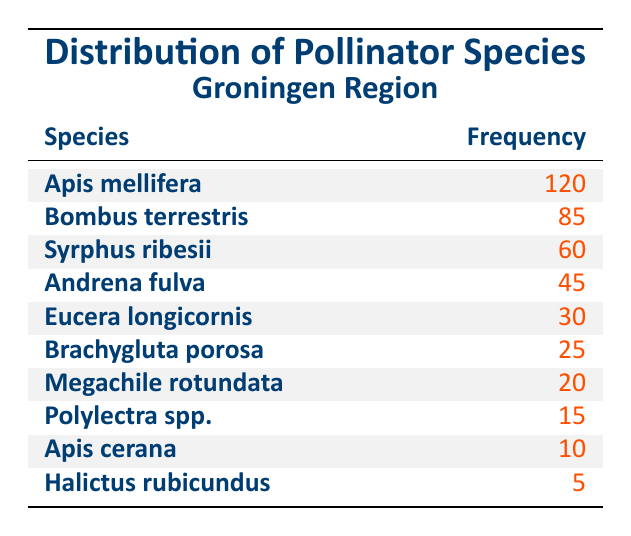What is the most frequently observed pollinator species in the Groningen region? The table lists pollinator species along with their frequencies. The species with the highest frequency is Apis mellifera, which has a frequency of 120.
Answer: Apis mellifera How many times more frequently is Bombus terrestris observed compared to Halictus rubicundus? Bombus terrestris has a frequency of 85, while Halictus rubicundus has a frequency of 5. To find how many times more frequently it is observed, divide: 85 / 5 = 17.
Answer: 17 What is the total frequency of the top three pollinator species? The top three species and their frequencies are: Apis mellifera (120), Bombus terrestris (85), and Syrphus ribesii (60). To find the total frequency, sum these values: 120 + 85 + 60 = 265.
Answer: 265 Is Apis cerana observed more frequently than Brachygluta porosa? Apis cerana has a frequency of 10, while Brachygluta porosa has a frequency of 25. Since 10 is less than 25, the statement is false.
Answer: No What is the average frequency of the pollinator species listed in the table? There are 10 pollinator species listed, and their total frequency is 120 + 85 + 60 + 45 + 30 + 25 + 20 + 15 + 10 + 5 = 415. To find the average, divide the total frequency by the number of species: 415 / 10 = 41.5.
Answer: 41.5 Which species has a frequency of 30? Looking at the table, Eucera longicornis is the species that has a frequency of 30.
Answer: Eucera longicornis How many species are observed with a frequency greater than 25? The species with frequencies greater than 25 are: Apis mellifera (120), Bombus terrestris (85), Syrphus ribesii (60), and Andrena fulva (45). This makes a total of 4 species.
Answer: 4 Which two pollinator species have the lowest frequencies? The species with the lowest frequencies are Halictus rubicundus (5) and Apis cerana (10). Thus, these are the two species with the least observations.
Answer: Halictus rubicundus and Apis cerana 